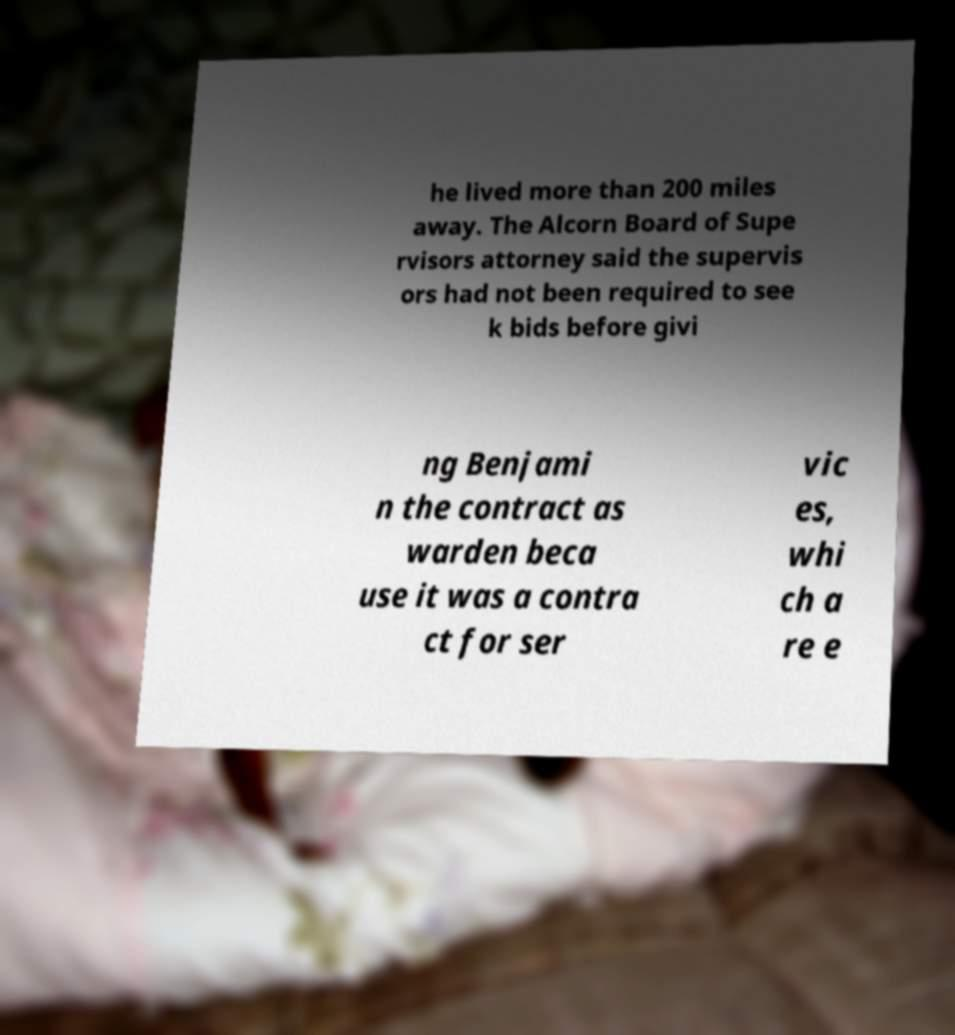Can you accurately transcribe the text from the provided image for me? he lived more than 200 miles away. The Alcorn Board of Supe rvisors attorney said the supervis ors had not been required to see k bids before givi ng Benjami n the contract as warden beca use it was a contra ct for ser vic es, whi ch a re e 